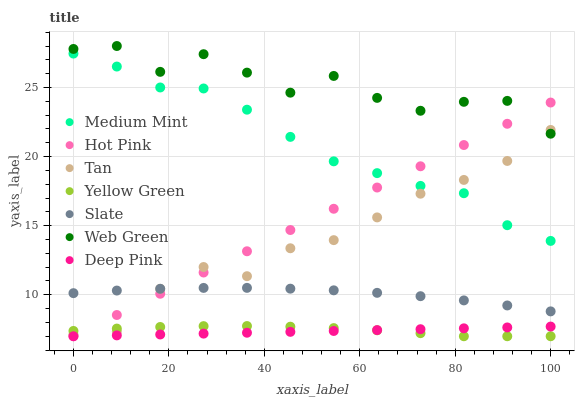Does Deep Pink have the minimum area under the curve?
Answer yes or no. Yes. Does Web Green have the maximum area under the curve?
Answer yes or no. Yes. Does Yellow Green have the minimum area under the curve?
Answer yes or no. No. Does Yellow Green have the maximum area under the curve?
Answer yes or no. No. Is Deep Pink the smoothest?
Answer yes or no. Yes. Is Web Green the roughest?
Answer yes or no. Yes. Is Yellow Green the smoothest?
Answer yes or no. No. Is Yellow Green the roughest?
Answer yes or no. No. Does Deep Pink have the lowest value?
Answer yes or no. Yes. Does Slate have the lowest value?
Answer yes or no. No. Does Web Green have the highest value?
Answer yes or no. Yes. Does Yellow Green have the highest value?
Answer yes or no. No. Is Yellow Green less than Slate?
Answer yes or no. Yes. Is Medium Mint greater than Slate?
Answer yes or no. Yes. Does Medium Mint intersect Tan?
Answer yes or no. Yes. Is Medium Mint less than Tan?
Answer yes or no. No. Is Medium Mint greater than Tan?
Answer yes or no. No. Does Yellow Green intersect Slate?
Answer yes or no. No. 